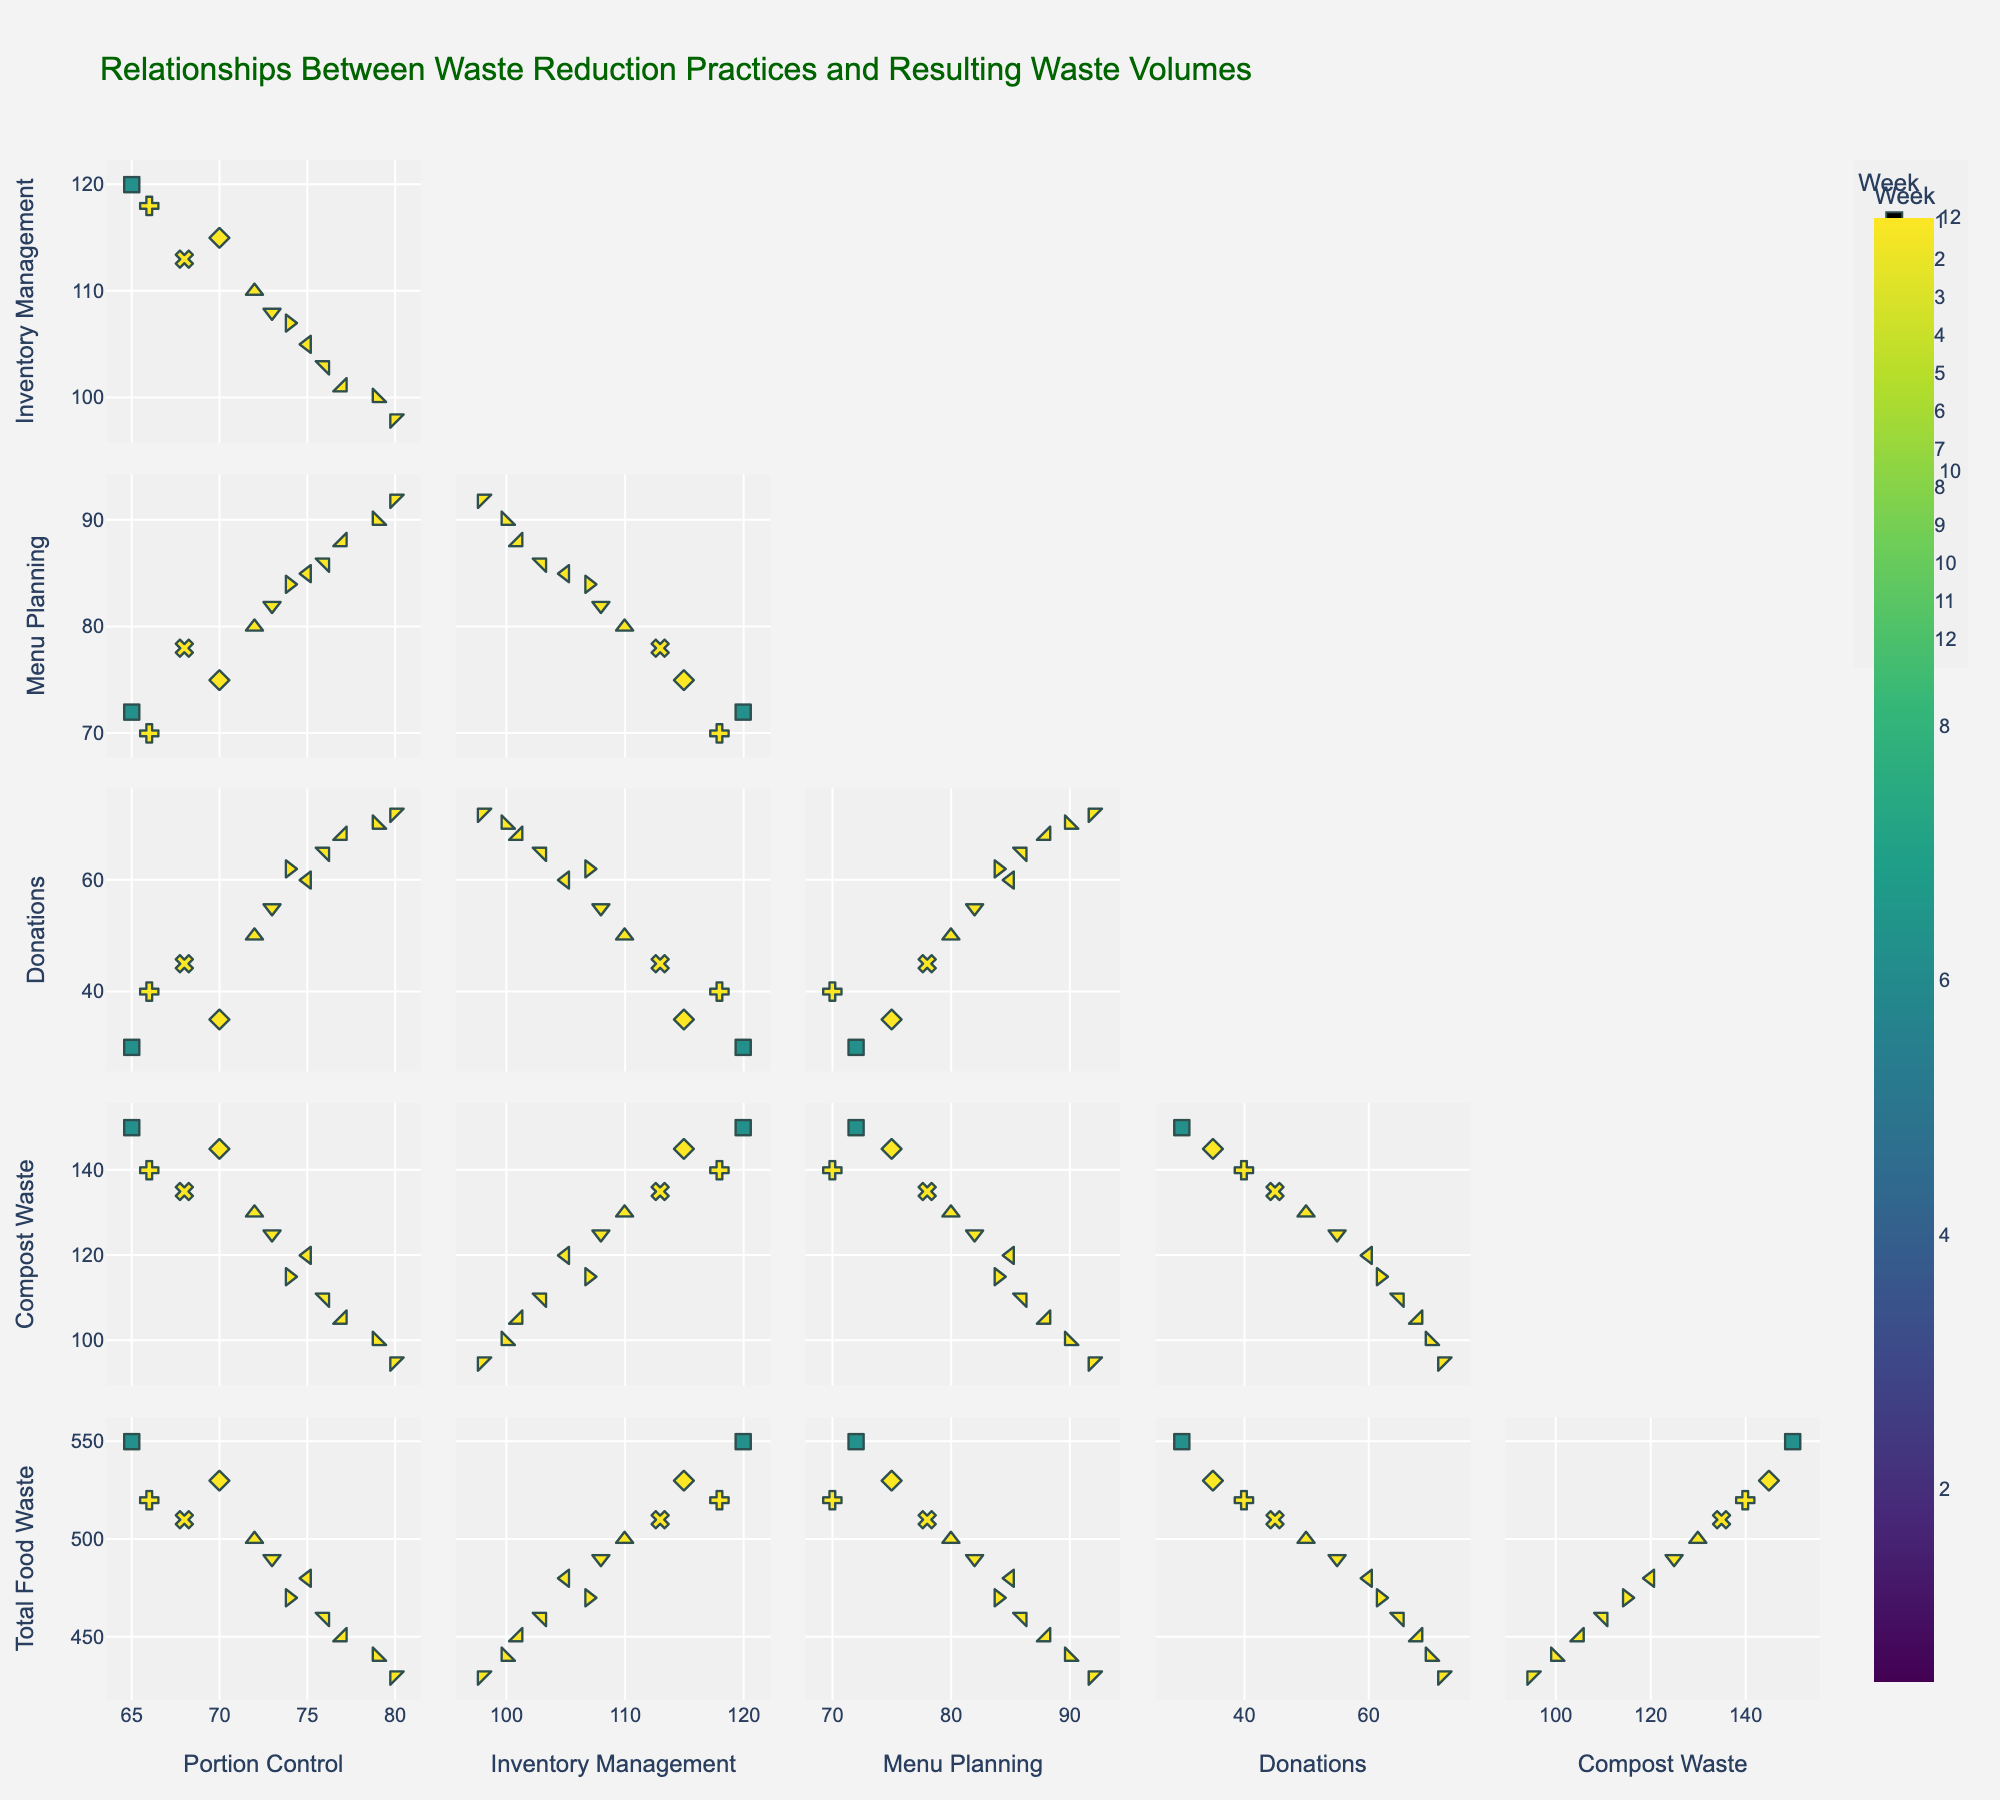What is the title of the scatter plot matrix? The title is found at the top of the scatter plot matrix. It indicates the overall topic or focus of the visualized data.
Answer: Relationships Between Waste Reduction Practices and Resulting Waste Volumes Which variable is used to color-code the data points? The color of the data points changes according to a specific variable, often mentioned in the legend or the color bar. In this case, the color represents the week number.
Answer: Week How are the diagonal elements of the matrix treated in this figure? Diagonal elements in a SPLOM often contain histograms or density plots of each variable. However, in this case, the description mentions that these diagonal elements are not visible, aiming for clearer comparisons between different variables.
Answer: Not visible What trend is observed between "Portion Control" and "Total Food Waste"? To identify trends, we look at the scatter plots between these variables. The plots show a negative trend, where an increase in portion control results in a decrease in total food waste.
Answer: Negative trend Is there a visible relationship between "Donations" and "Compost Waste"? To determine if there is a relationship, observe the scatter plot between these two variables. The plot shows a positive trend, where increased donations correlate with increased compost waste.
Answer: Positive trend What is the highest "Portion Control" value recorded, and which week does it correspond to? First, identify the scatter plot of Portion Control against Week. Then, look for the highest value on the y-axis marking "Portion Control" and see the corresponding x-axis value.
Answer: 80, Week 12 Which week has the lowest "Total Food Waste" and what is that value? Examine the scatter plot of Total Food Waste against Week. The week with the lowest value on the y-axis (Total Food Waste) needs to be identified.
Answer: Week 12, 430 Which variable shows the strongest correlation with "Inventory Management"? Identify the scatter plot of Inventory Management with other variables. The variable with the scatter plot showing the most linear relationship with Inventory Management indicates the strongest correlation.
Answer: Menu Planning By how much did the "Total Food Waste" decrease from Week 1 to Week 12? Look at the values of "Total Food Waste" for Week 1 and Week 12 and calculate the difference. Week 1 has 550 and Week 12 has 430. Subtract 430 from 550.
Answer: 120 Is there a visible pattern when comparing "Menu Planning" with "Compost Waste"? Check the scatter plot of Menu Planning against Compost Waste and determine if there is a discernible pattern, such as a positive or negative trend.
Answer: Positive trend 